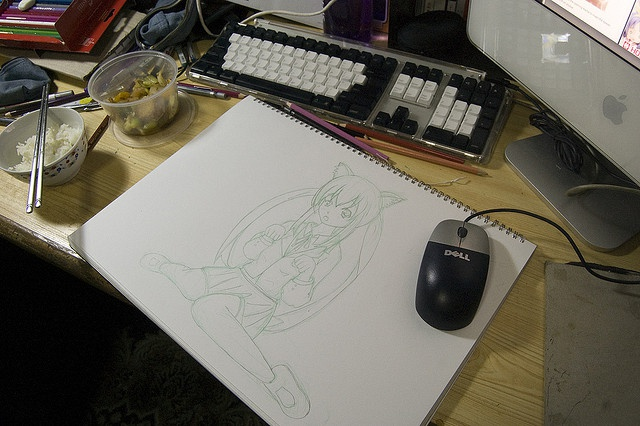Describe the objects in this image and their specific colors. I can see book in blue, darkgray, lightgray, and gray tones, tv in blue, darkgray, black, and gray tones, keyboard in blue, black, darkgray, and gray tones, bowl in blue, gray, olive, and black tones, and mouse in blue, black, gray, and darkgray tones in this image. 